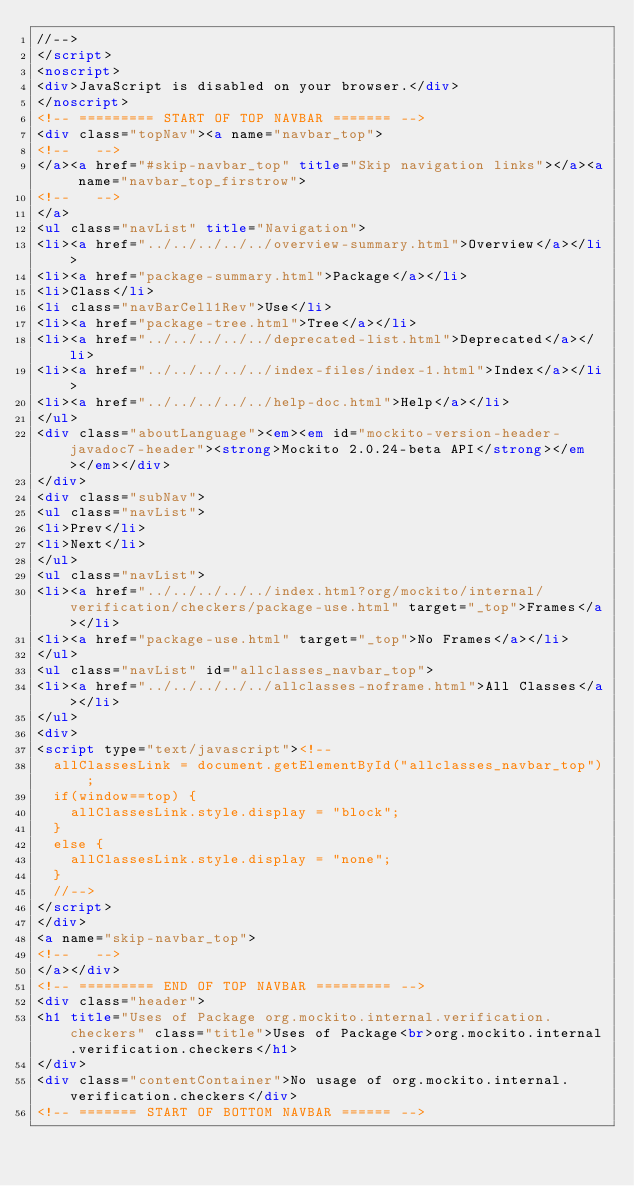<code> <loc_0><loc_0><loc_500><loc_500><_HTML_>//-->
</script>
<noscript>
<div>JavaScript is disabled on your browser.</div>
</noscript>
<!-- ========= START OF TOP NAVBAR ======= -->
<div class="topNav"><a name="navbar_top">
<!--   -->
</a><a href="#skip-navbar_top" title="Skip navigation links"></a><a name="navbar_top_firstrow">
<!--   -->
</a>
<ul class="navList" title="Navigation">
<li><a href="../../../../../overview-summary.html">Overview</a></li>
<li><a href="package-summary.html">Package</a></li>
<li>Class</li>
<li class="navBarCell1Rev">Use</li>
<li><a href="package-tree.html">Tree</a></li>
<li><a href="../../../../../deprecated-list.html">Deprecated</a></li>
<li><a href="../../../../../index-files/index-1.html">Index</a></li>
<li><a href="../../../../../help-doc.html">Help</a></li>
</ul>
<div class="aboutLanguage"><em><em id="mockito-version-header-javadoc7-header"><strong>Mockito 2.0.24-beta API</strong></em></em></div>
</div>
<div class="subNav">
<ul class="navList">
<li>Prev</li>
<li>Next</li>
</ul>
<ul class="navList">
<li><a href="../../../../../index.html?org/mockito/internal/verification/checkers/package-use.html" target="_top">Frames</a></li>
<li><a href="package-use.html" target="_top">No Frames</a></li>
</ul>
<ul class="navList" id="allclasses_navbar_top">
<li><a href="../../../../../allclasses-noframe.html">All Classes</a></li>
</ul>
<div>
<script type="text/javascript"><!--
  allClassesLink = document.getElementById("allclasses_navbar_top");
  if(window==top) {
    allClassesLink.style.display = "block";
  }
  else {
    allClassesLink.style.display = "none";
  }
  //-->
</script>
</div>
<a name="skip-navbar_top">
<!--   -->
</a></div>
<!-- ========= END OF TOP NAVBAR ========= -->
<div class="header">
<h1 title="Uses of Package org.mockito.internal.verification.checkers" class="title">Uses of Package<br>org.mockito.internal.verification.checkers</h1>
</div>
<div class="contentContainer">No usage of org.mockito.internal.verification.checkers</div>
<!-- ======= START OF BOTTOM NAVBAR ====== --></code> 